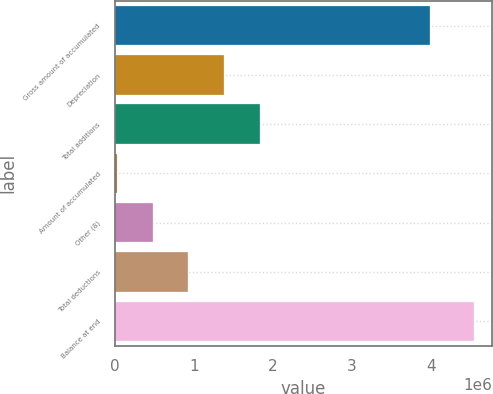Convert chart. <chart><loc_0><loc_0><loc_500><loc_500><bar_chart><fcel>Gross amount of accumulated<fcel>Depreciation<fcel>Total additions<fcel>Amount of accumulated<fcel>Other (8)<fcel>Total deductions<fcel>Balance at end<nl><fcel>3.99487e+06<fcel>1.38187e+06<fcel>1.83418e+06<fcel>24911<fcel>477230<fcel>929548<fcel>4.5481e+06<nl></chart> 